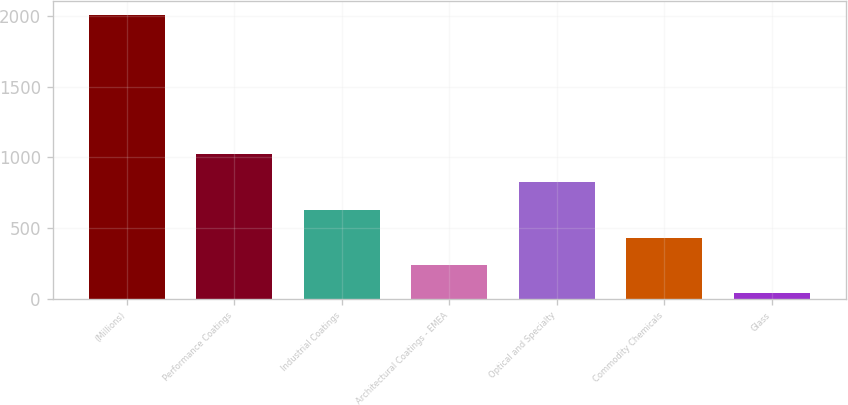<chart> <loc_0><loc_0><loc_500><loc_500><bar_chart><fcel>(Millions)<fcel>Performance Coatings<fcel>Industrial Coatings<fcel>Architectural Coatings - EMEA<fcel>Optical and Specialty<fcel>Commodity Chemicals<fcel>Glass<nl><fcel>2009<fcel>1024<fcel>630<fcel>236<fcel>827<fcel>433<fcel>39<nl></chart> 